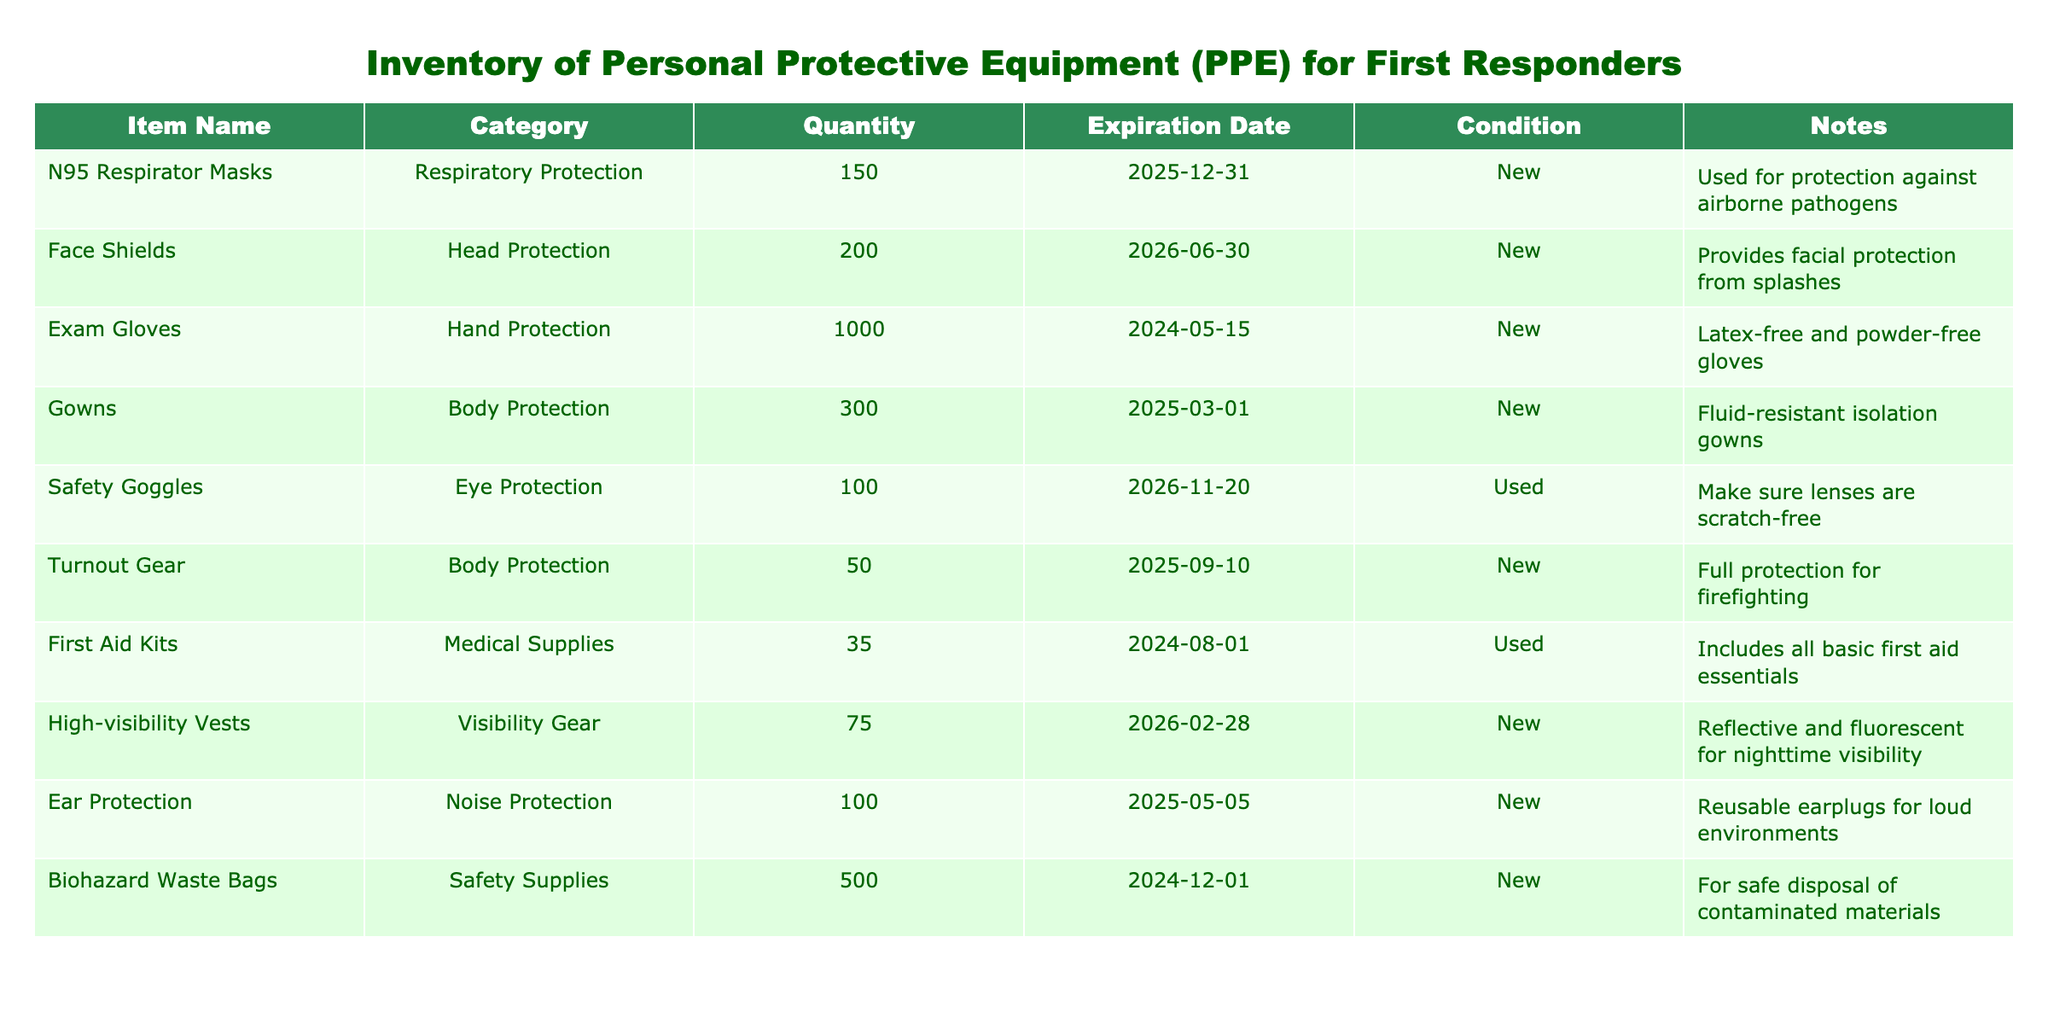What is the total quantity of Exam Gloves in the inventory? The quantity of Exam Gloves listed in the table is 1000. This is a direct retrieval of the information provided in the table without any calculations required.
Answer: 1000 What is the expiration date of the Face Shields? The table shows that the expiration date of the Face Shields is June 30, 2026. This is also a direct retrieval from the table.
Answer: 2026-06-30 How many items are classified under Body Protection? There are two items under the Body Protection category: Gowns (300) and Turnout Gear (50). Therefore, the total quantity is 300 + 50 = 350. This involved summing the quantities from both Body Protection items.
Answer: 350 Are the N95 Respirator Masks new or used? The table indicates that N95 Respirator Masks are classified as "New." This is a straightforward retrieval of the condition column related to that item.
Answer: New Is the quantity of High-visibility Vests greater than that of Turnout Gear? The quantity of High-visibility Vests is listed as 75, while the quantity of Turnout Gear is 50. Since 75 is greater than 50, the answer is yes. This comparison involves checking both quantities and confirming the relationship.
Answer: Yes What is the total quantity of PPE items listed as new? The items that are new include N95 Respirator Masks (150), Face Shields (200), Exam Gloves (1000), Gowns (300), Turnout Gear (50), High-visibility Vests (75), and Ear Protection (100). Adding these gives us a total of 150 + 200 + 1000 + 300 + 50 + 75 + 100 = 1875. This question requires summing the quantities of all new items listed in the table.
Answer: 1875 Are the Safety Goggles in good condition? The condition of the Safety Goggles is listed as "Used," as per the table. Since "Used" indicates they may not be in optimal condition, the answer is no. This is a simple retrieval of the condition information.
Answer: No If we consider only medical supplies, what is the total quantity? The only item listed under medical supplies is First Aid Kits, with a quantity of 35. Since there is just one item, its quantity is the total. This question is straightforward since it involves identifying the category and retrieving the quantity.
Answer: 35 What is the difference in quantity between Biohazard Waste Bags and Face Shields? The quantity of Biohazard Waste Bags is 500 and the quantity of Face Shields is 200. The difference is calculated as 500 - 200 = 300. This question involves basic subtraction and comparison of two quantities in the inventory.
Answer: 300 